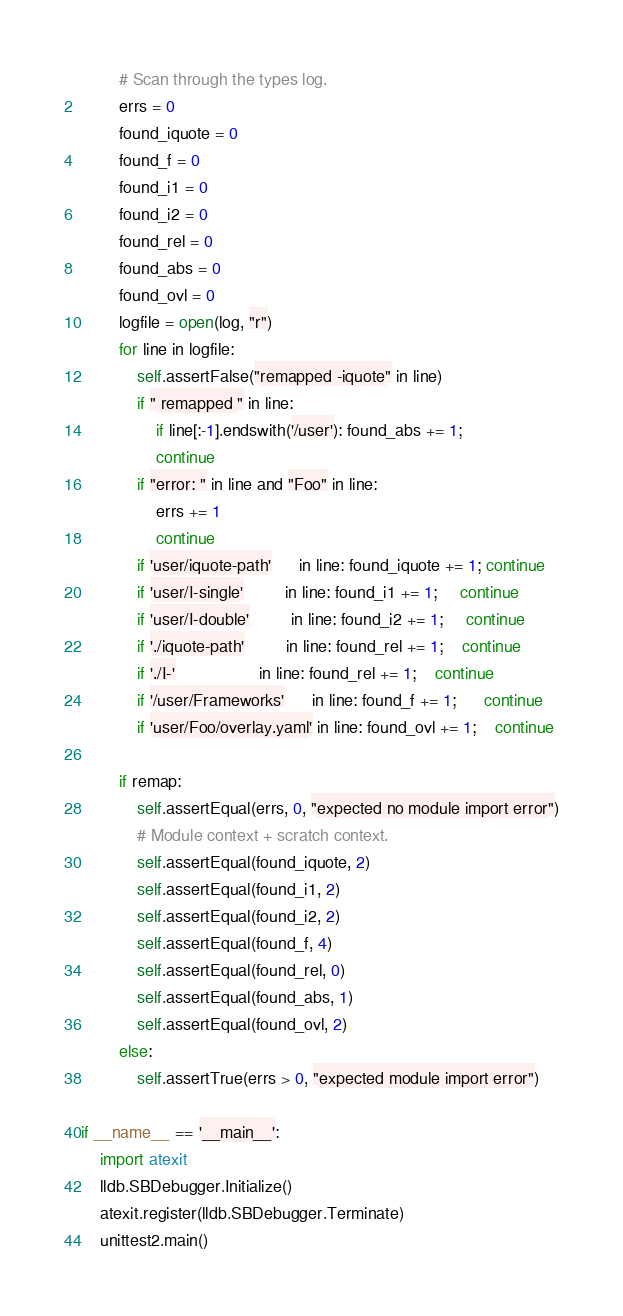<code> <loc_0><loc_0><loc_500><loc_500><_Python_>
        # Scan through the types log.
        errs = 0
        found_iquote = 0
        found_f = 0
        found_i1 = 0
        found_i2 = 0
        found_rel = 0
        found_abs = 0
        found_ovl = 0
        logfile = open(log, "r")
        for line in logfile:
            self.assertFalse("remapped -iquote" in line)
            if " remapped " in line:
                if line[:-1].endswith('/user'): found_abs += 1;
                continue
            if "error: " in line and "Foo" in line:
                errs += 1
                continue
            if 'user/iquote-path'      in line: found_iquote += 1; continue
            if 'user/I-single'         in line: found_i1 += 1;     continue
            if 'user/I-double'         in line: found_i2 += 1;     continue
            if './iquote-path'         in line: found_rel += 1;    continue
            if './I-'                  in line: found_rel += 1;    continue
            if '/user/Frameworks'      in line: found_f += 1;      continue
            if 'user/Foo/overlay.yaml' in line: found_ovl += 1;    continue

        if remap:
            self.assertEqual(errs, 0, "expected no module import error")
            # Module context + scratch context.
            self.assertEqual(found_iquote, 2)
            self.assertEqual(found_i1, 2)
            self.assertEqual(found_i2, 2)
            self.assertEqual(found_f, 4)
            self.assertEqual(found_rel, 0)
            self.assertEqual(found_abs, 1)
            self.assertEqual(found_ovl, 2)
        else:
            self.assertTrue(errs > 0, "expected module import error")
        
if __name__ == '__main__':
    import atexit
    lldb.SBDebugger.Initialize()
    atexit.register(lldb.SBDebugger.Terminate)
    unittest2.main()
</code> 